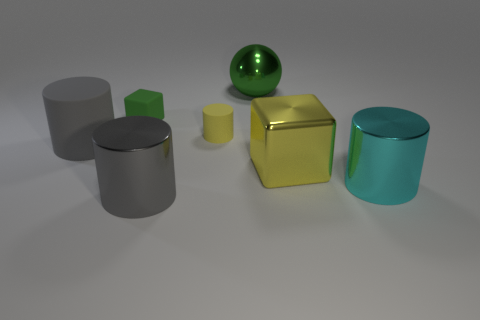Are there an equal number of yellow cubes that are left of the big metal sphere and large metallic cylinders that are to the right of the gray matte cylinder?
Your answer should be compact. No. There is a big metallic object that is behind the big gray thing behind the large gray cylinder in front of the large yellow cube; what color is it?
Your answer should be very brief. Green. Are there any other things that are the same color as the large metal sphere?
Keep it short and to the point. Yes. The metal object that is the same color as the small matte cube is what shape?
Ensure brevity in your answer.  Sphere. What is the size of the gray thing behind the large yellow block?
Your answer should be very brief. Large. What shape is the cyan object that is the same size as the metallic ball?
Make the answer very short. Cylinder. Is the material of the big gray object in front of the yellow cube the same as the yellow object in front of the tiny yellow thing?
Your response must be concise. Yes. What is the big gray object that is to the right of the big rubber cylinder that is in front of the small yellow object made of?
Offer a terse response. Metal. What size is the gray thing that is in front of the shiny thing right of the yellow object that is to the right of the large ball?
Your answer should be compact. Large. Does the green metal ball have the same size as the yellow rubber object?
Ensure brevity in your answer.  No. 